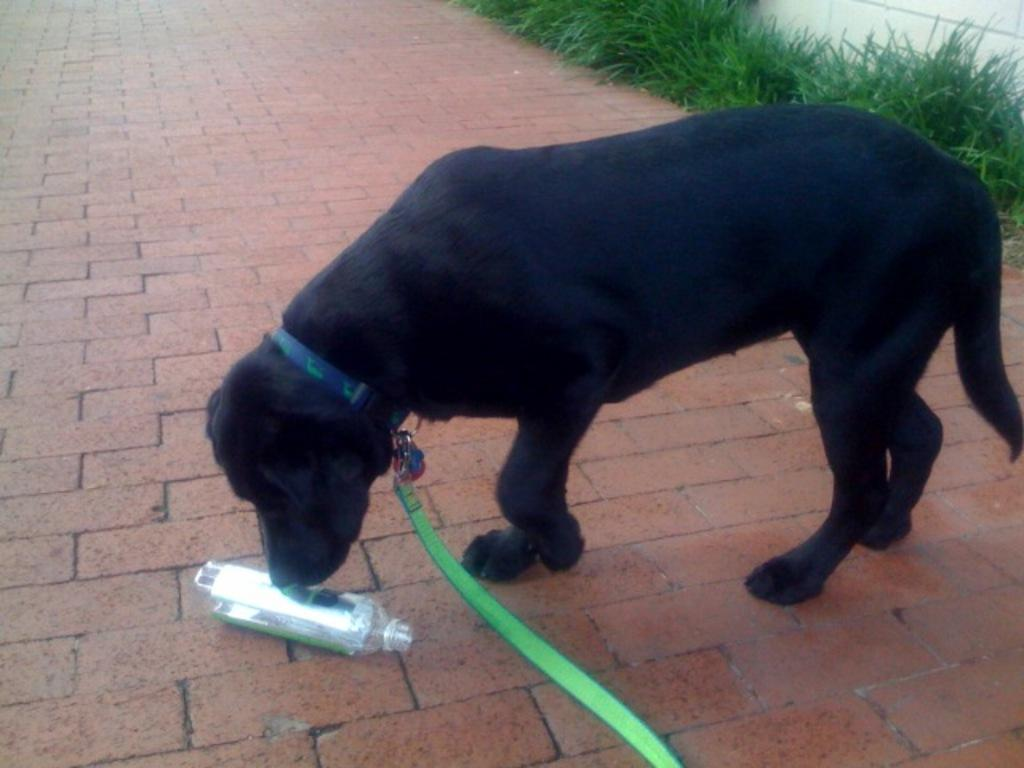What type of animal is in the image? There is a black dog in the image. What is the dog doing in the image? The dog is standing. What object can be seen near the dog? There is a bottle in the image. On what surface is the bottle placed? The bottle is on tiles. What can be seen in the background of the image? There is grass visible in the background of the image. What type of letter is the robin delivering in the image? There is no robin or letter present in the image. 